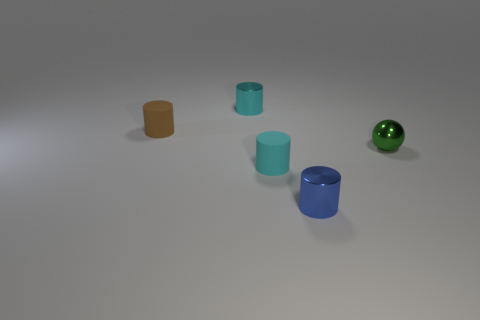Can you describe the texture of the objects displayed? The objects in the image all exhibit a smooth texture with a slightly reflective surface, suggesting they are likely made of a plastic or glossy-painted material. 